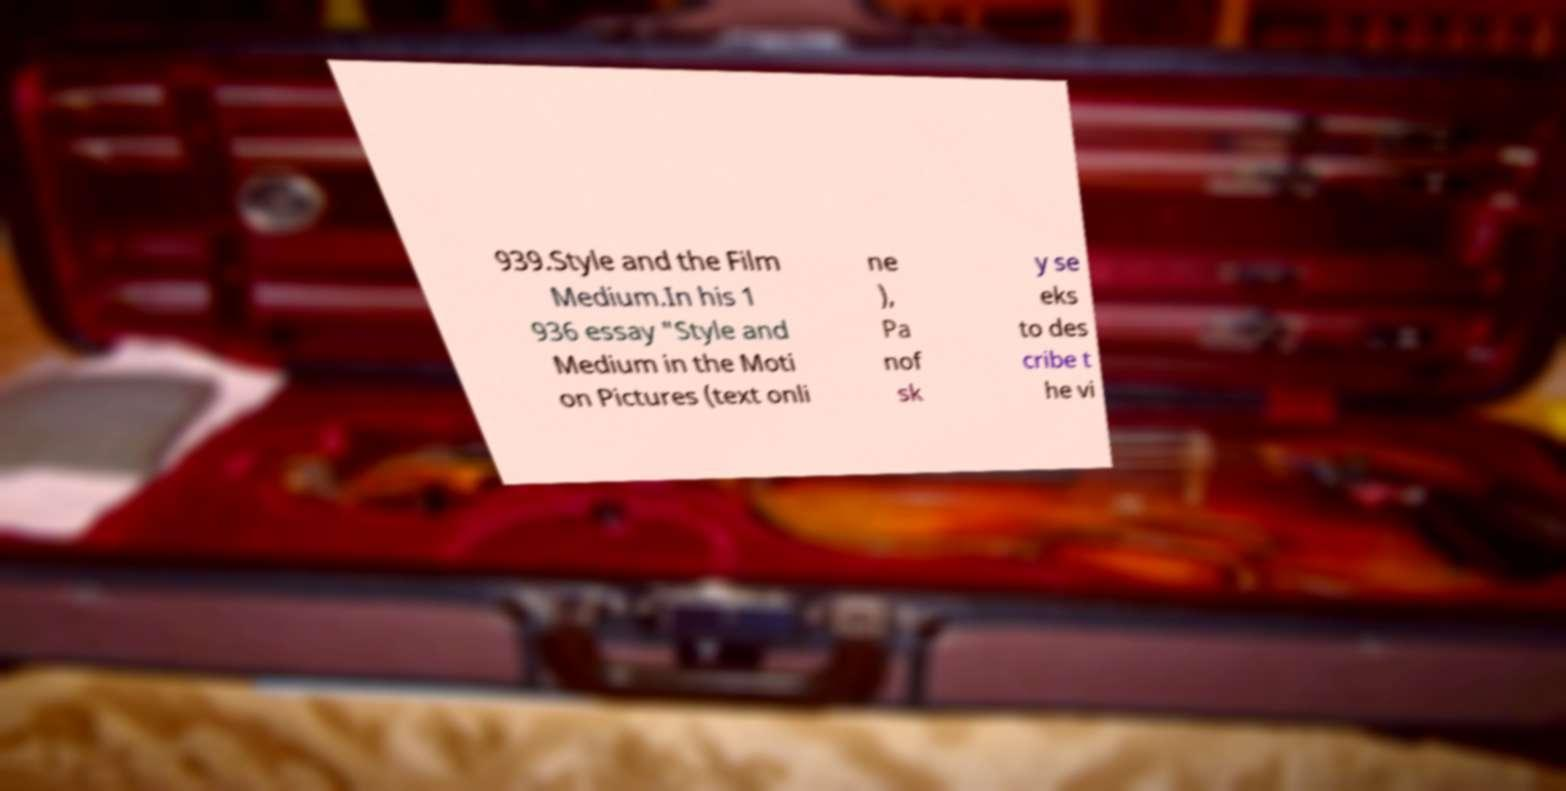Can you read and provide the text displayed in the image?This photo seems to have some interesting text. Can you extract and type it out for me? 939.Style and the Film Medium.In his 1 936 essay "Style and Medium in the Moti on Pictures (text onli ne ), Pa nof sk y se eks to des cribe t he vi 